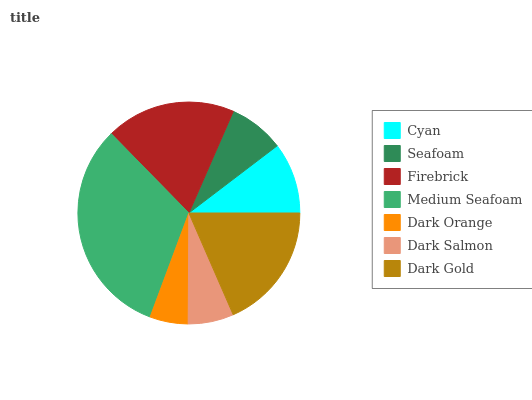Is Dark Orange the minimum?
Answer yes or no. Yes. Is Medium Seafoam the maximum?
Answer yes or no. Yes. Is Seafoam the minimum?
Answer yes or no. No. Is Seafoam the maximum?
Answer yes or no. No. Is Cyan greater than Seafoam?
Answer yes or no. Yes. Is Seafoam less than Cyan?
Answer yes or no. Yes. Is Seafoam greater than Cyan?
Answer yes or no. No. Is Cyan less than Seafoam?
Answer yes or no. No. Is Cyan the high median?
Answer yes or no. Yes. Is Cyan the low median?
Answer yes or no. Yes. Is Firebrick the high median?
Answer yes or no. No. Is Medium Seafoam the low median?
Answer yes or no. No. 